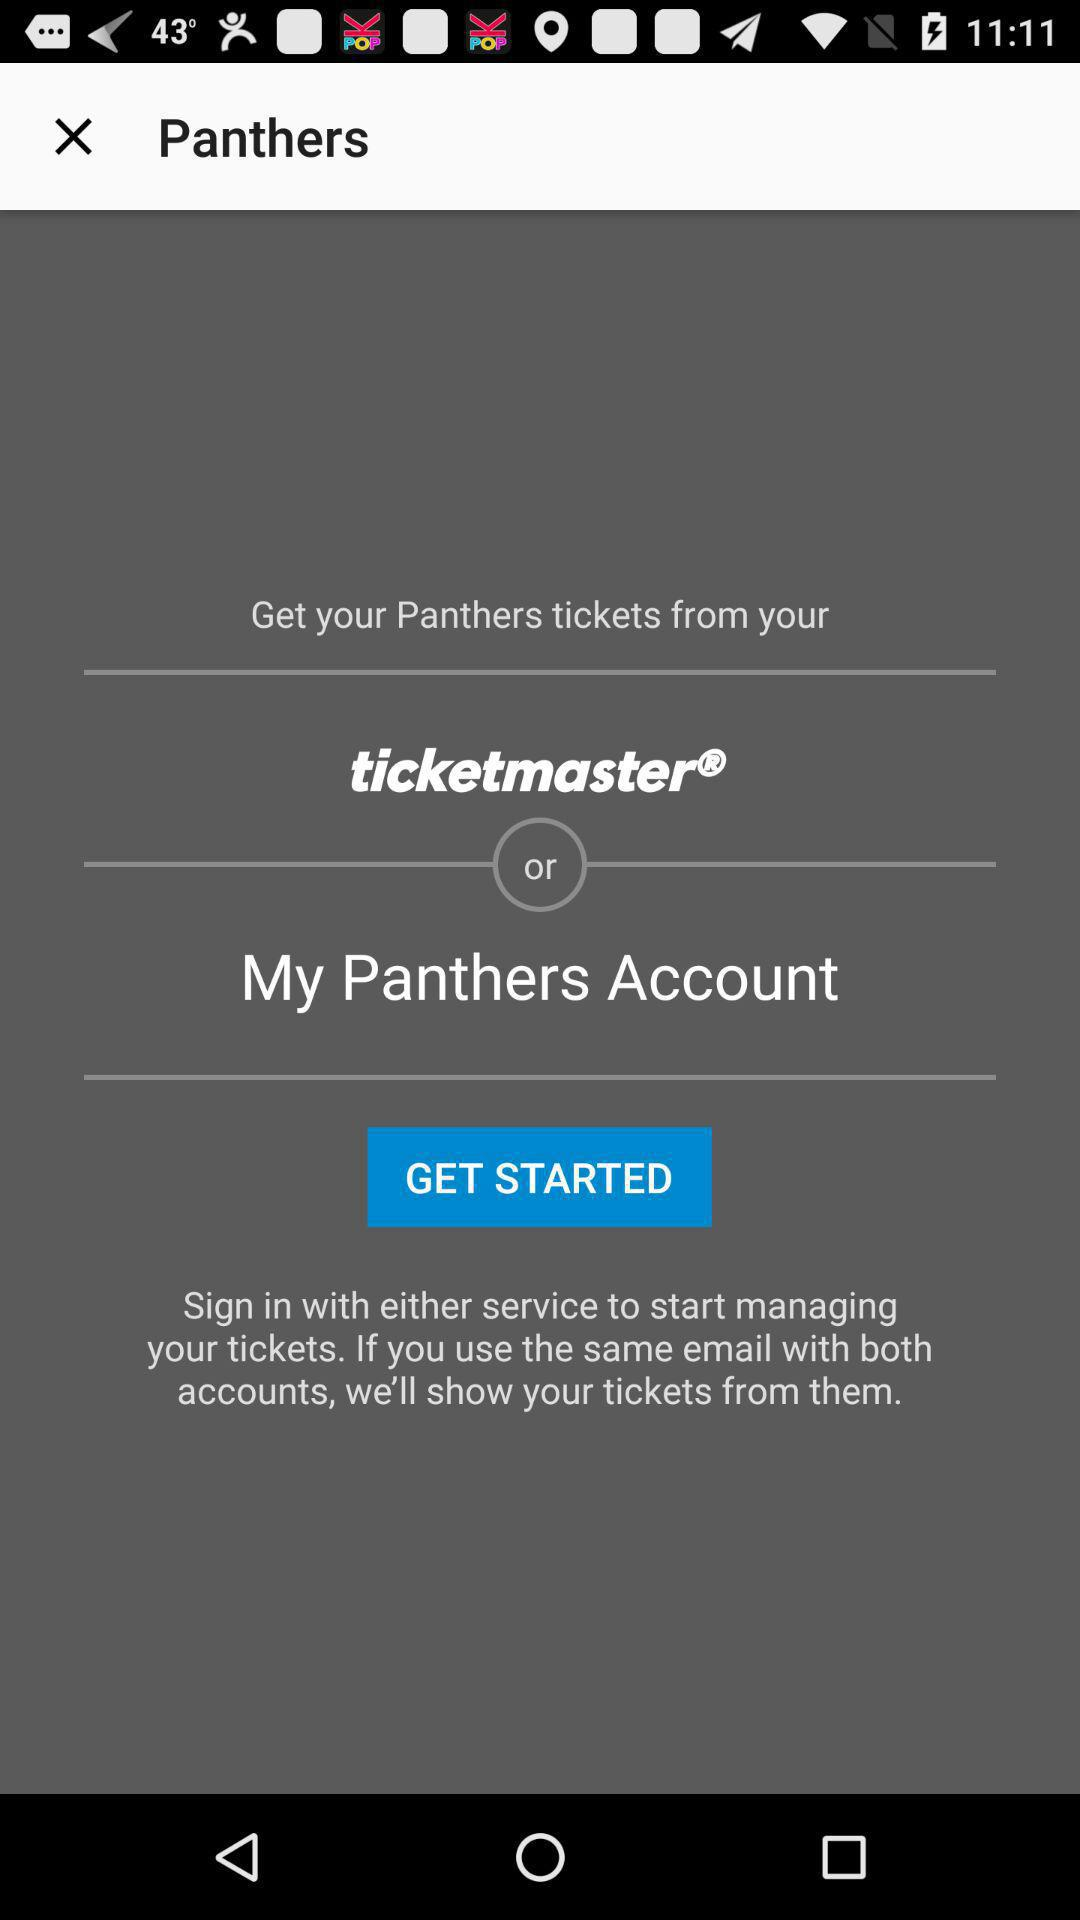Which sport do the "Panthers" play?
When the provided information is insufficient, respond with <no answer>. <no answer> 